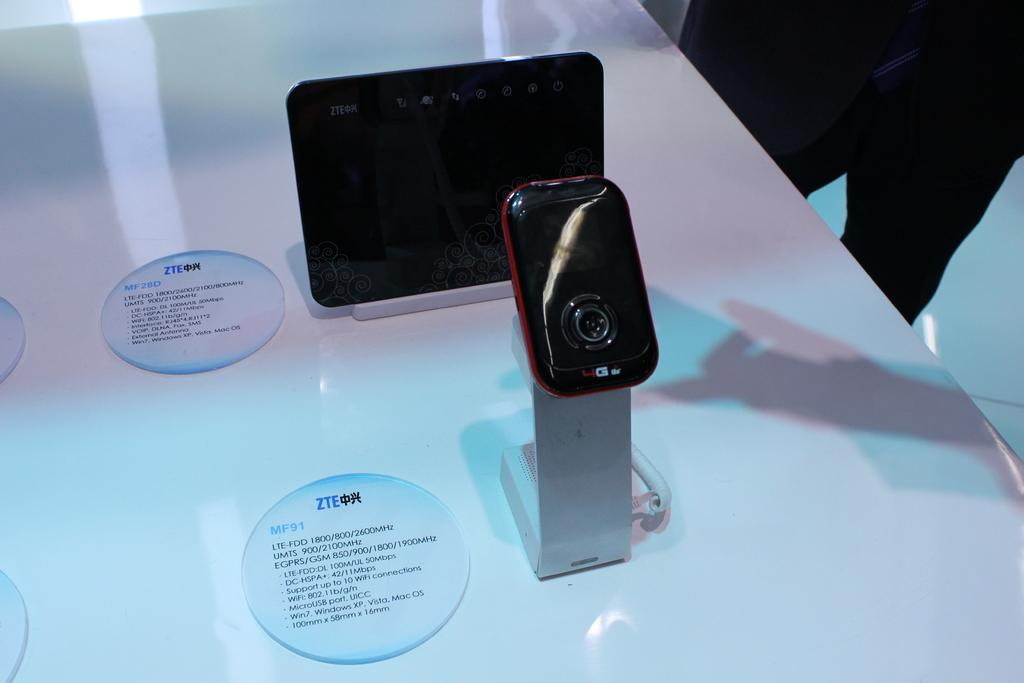<image>
Summarize the visual content of the image. 2 Zte devices on display with the model number MF01 on the first device. 